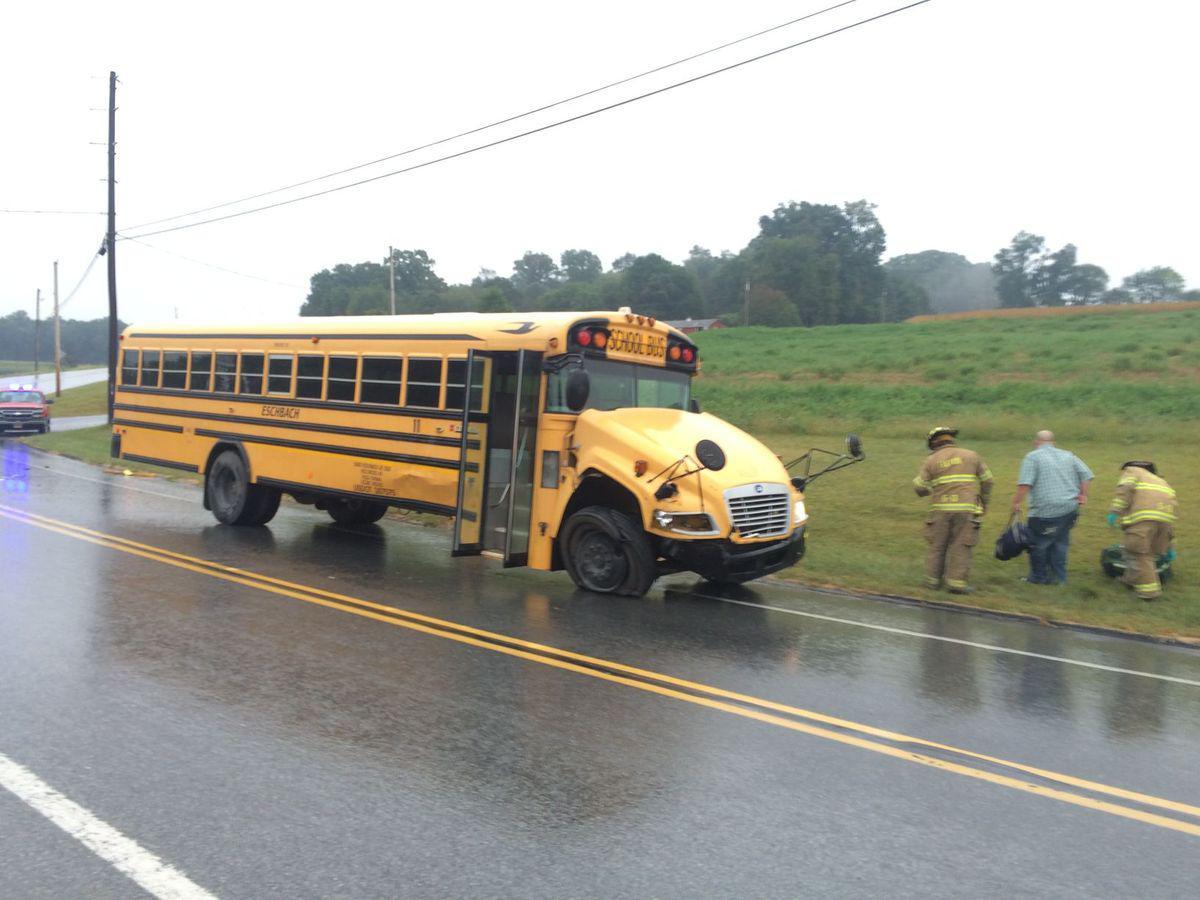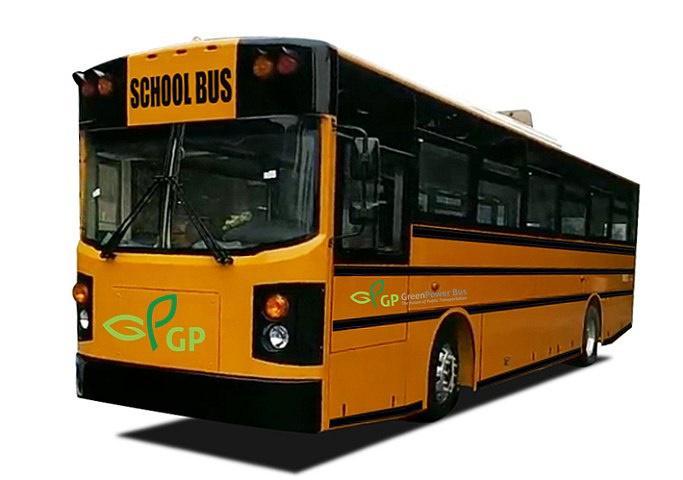The first image is the image on the left, the second image is the image on the right. Evaluate the accuracy of this statement regarding the images: "There are more buses in the image on the left.". Is it true? Answer yes or no. No. The first image is the image on the left, the second image is the image on the right. Given the left and right images, does the statement "The right image shows one flat-fronted bus displayed diagonally and forward-facing, and the left image includes at least one bus that has a non-flat front." hold true? Answer yes or no. Yes. 